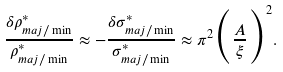Convert formula to latex. <formula><loc_0><loc_0><loc_500><loc_500>\frac { \delta \rho ^ { * } _ { m a j / \min } } { \rho ^ { * } _ { m a j / \min } } \approx - \frac { \delta \sigma ^ { * } _ { m a j / \min } } { \sigma ^ { * } _ { m a j / \min } } \approx \pi ^ { 2 } \Big { ( } \frac { A } { \xi } \Big { ) } ^ { 2 } .</formula> 